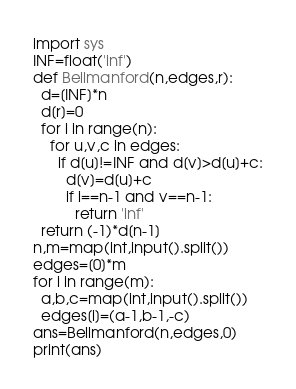<code> <loc_0><loc_0><loc_500><loc_500><_Python_>import sys
INF=float('inf')
def Bellmanford(n,edges,r):
  d=[INF]*n
  d[r]=0
  for i in range(n):
    for u,v,c in edges:
      if d[u]!=INF and d[v]>d[u]+c:
        d[v]=d[u]+c
        if i==n-1 and v==n-1:
          return 'inf'
  return (-1)*d[n-1]
n,m=map(int,input().split())
edges=[0]*m
for i in range(m):
  a,b,c=map(int,input().split())
  edges[i]=(a-1,b-1,-c)
ans=Bellmanford(n,edges,0)
print(ans)</code> 